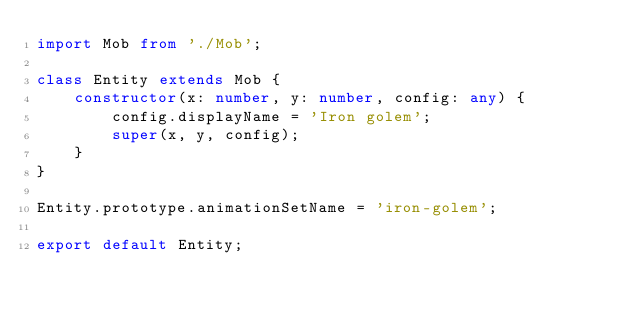Convert code to text. <code><loc_0><loc_0><loc_500><loc_500><_TypeScript_>import Mob from './Mob';

class Entity extends Mob {
    constructor(x: number, y: number, config: any) {
        config.displayName = 'Iron golem';
        super(x, y, config);
    }
}

Entity.prototype.animationSetName = 'iron-golem';

export default Entity;
</code> 